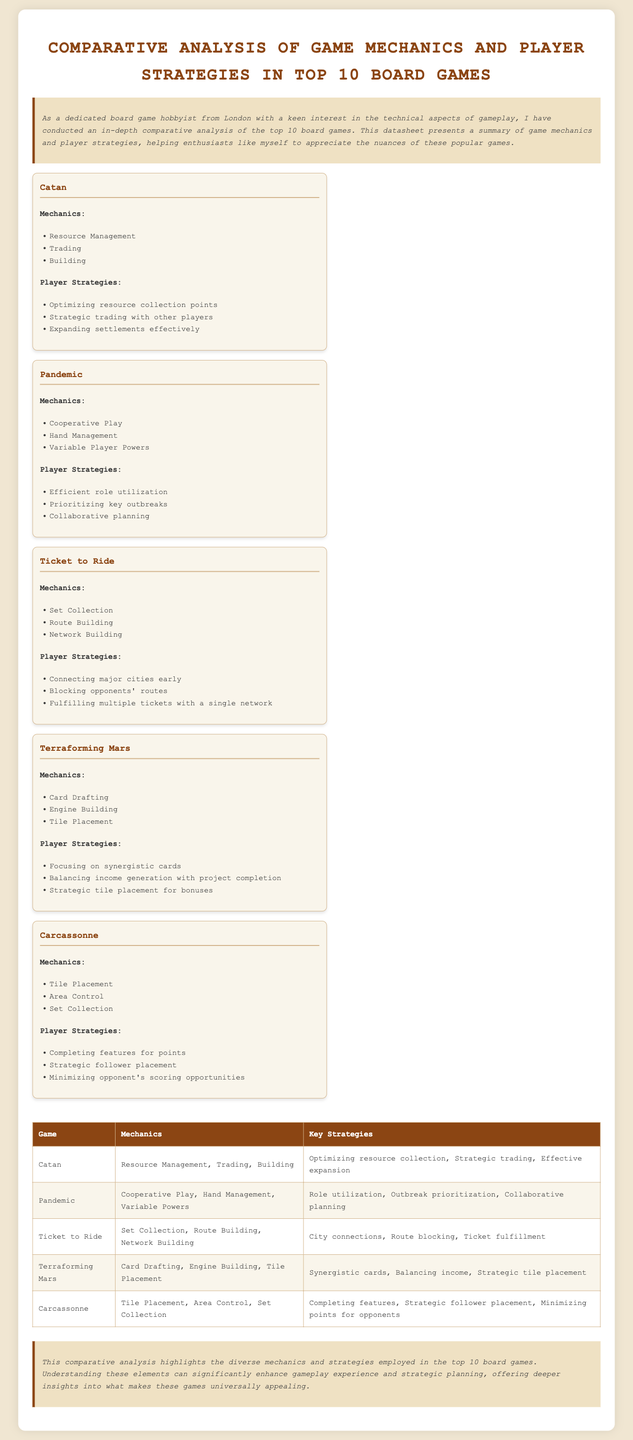What are the game mechanics of Catan? The game mechanics of Catan include resource management, trading, and building.
Answer: Resource Management, Trading, Building What is one key strategy for playing Pandemic? One key strategy for playing Pandemic is utilizing roles efficiently.
Answer: Efficient role utilization Which game involves route building mechanics? Among the listed games, Ticket to Ride involves route building mechanics.
Answer: Ticket to Ride How many games are listed in the analysis? The document presents a comparative analysis of the top 10 board games.
Answer: 10 What is the primary type of play in Pandemic? The primary type of play in Pandemic is cooperative play.
Answer: Cooperative Play Which game focuses on engine building mechanics? Terraforming Mars focuses on engine building mechanics as one of its key mechanics.
Answer: Terraforming Mars What is a common strategy in Carcassonne? A common strategy in Carcassonne is completing features for points.
Answer: Completing features Which game has trading as a mechanic? Catan has trading as one of its mechanics.
Answer: Catan What is the conclusion about the games analyzed? The conclusion highlights the diverse mechanics and strategies of the top 10 board games.
Answer: Diverse mechanics and strategies 